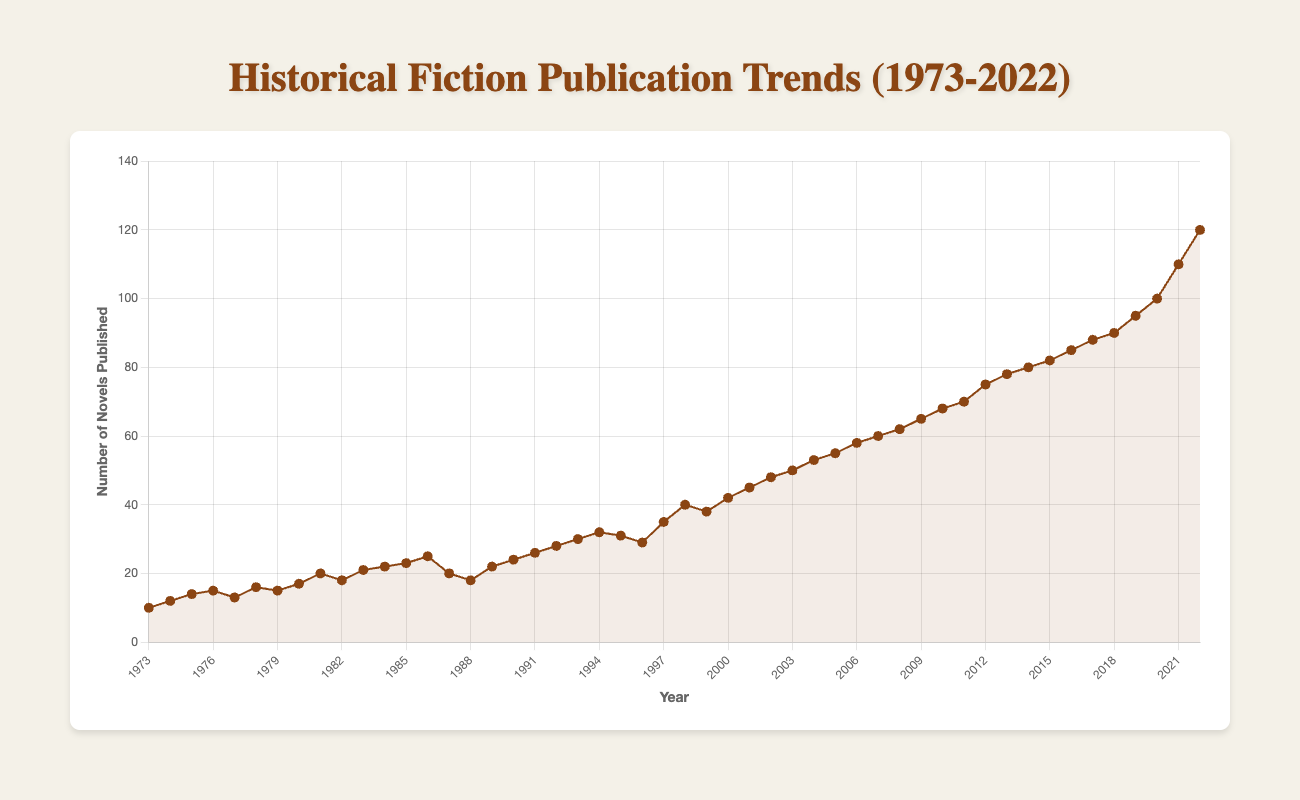What is the overall trend in the number of historical fiction novels published from 1973 to 2022? The overall trend shows a steady increase in the number of historical fiction novels published over the years. Starting from 10 novels in 1973 and reaching 120 novels in 2022, there is a clear upward trajectory.
Answer: Steady increase Which year experienced the highest number of novels published? By examining the data points on the line chart, the highest number of novels published is in the year 2022 with a total of 120 novels.
Answer: 2022 How many more novels were published in 1986 compared to 1973? In 1973, 10 novels were published, and in 1986, 25 novels were published. The difference is calculated as 25 - 10.
Answer: 15 During which decade did the number of novels published increase the most? By analyzing the data trends for each decade (noting the changes in slope of the line), the most significant increase appears in the decade of 2000 to 2010, where the number of novels published rose from 42 in 2000 to 68 in 2010. This increase is 26 novels over the decade.
Answer: 2000-2010 What was the average number of novels published per year between 1973 and 1983? Summing up the novels published yearly from 1973 to 1983 (10+12+14+15+13+16+15+17+20+18+21) = 171 novels. Dividing by the number of years (11 years), the average number is 171/11.
Answer: 15.55 How does the number of novels published in 1998 compare to that in 2008? In 1998, the number of novels published was 40, and in 2008, it was 62. Comparing the two, 62 novels in 2008 is greater than 40 in 1998 by 22 novels.
Answer: 62 > 40 by 22 novels What pattern can you observe in the publication trend between 1986 and 1988? Between 1986 and 1988, the number of novels published decreased, going from 25 in 1986 to 18 in 1988, indicating a downward slope in the line chart.
Answer: Decrease What is the difference in the number of novels published between the years 2002 and 2022? In 2002, 48 novels were published, and in 2022, 120 novels were published. The difference between these years is 120 - 48.
Answer: 72 How does the publication trend between 2010 and 2020 compare to the trend between 1980 and 1990? Observing the line chart, the increase from 2010 to 2020 is sharp, going from 68 to 100, a total of 32 novels. Between 1980 and 1990, the increase is gradual, from 17 to 24, only 7 novels. The recent decade shows a steeper growth.
Answer: 2010-2020 shows a steeper growth 